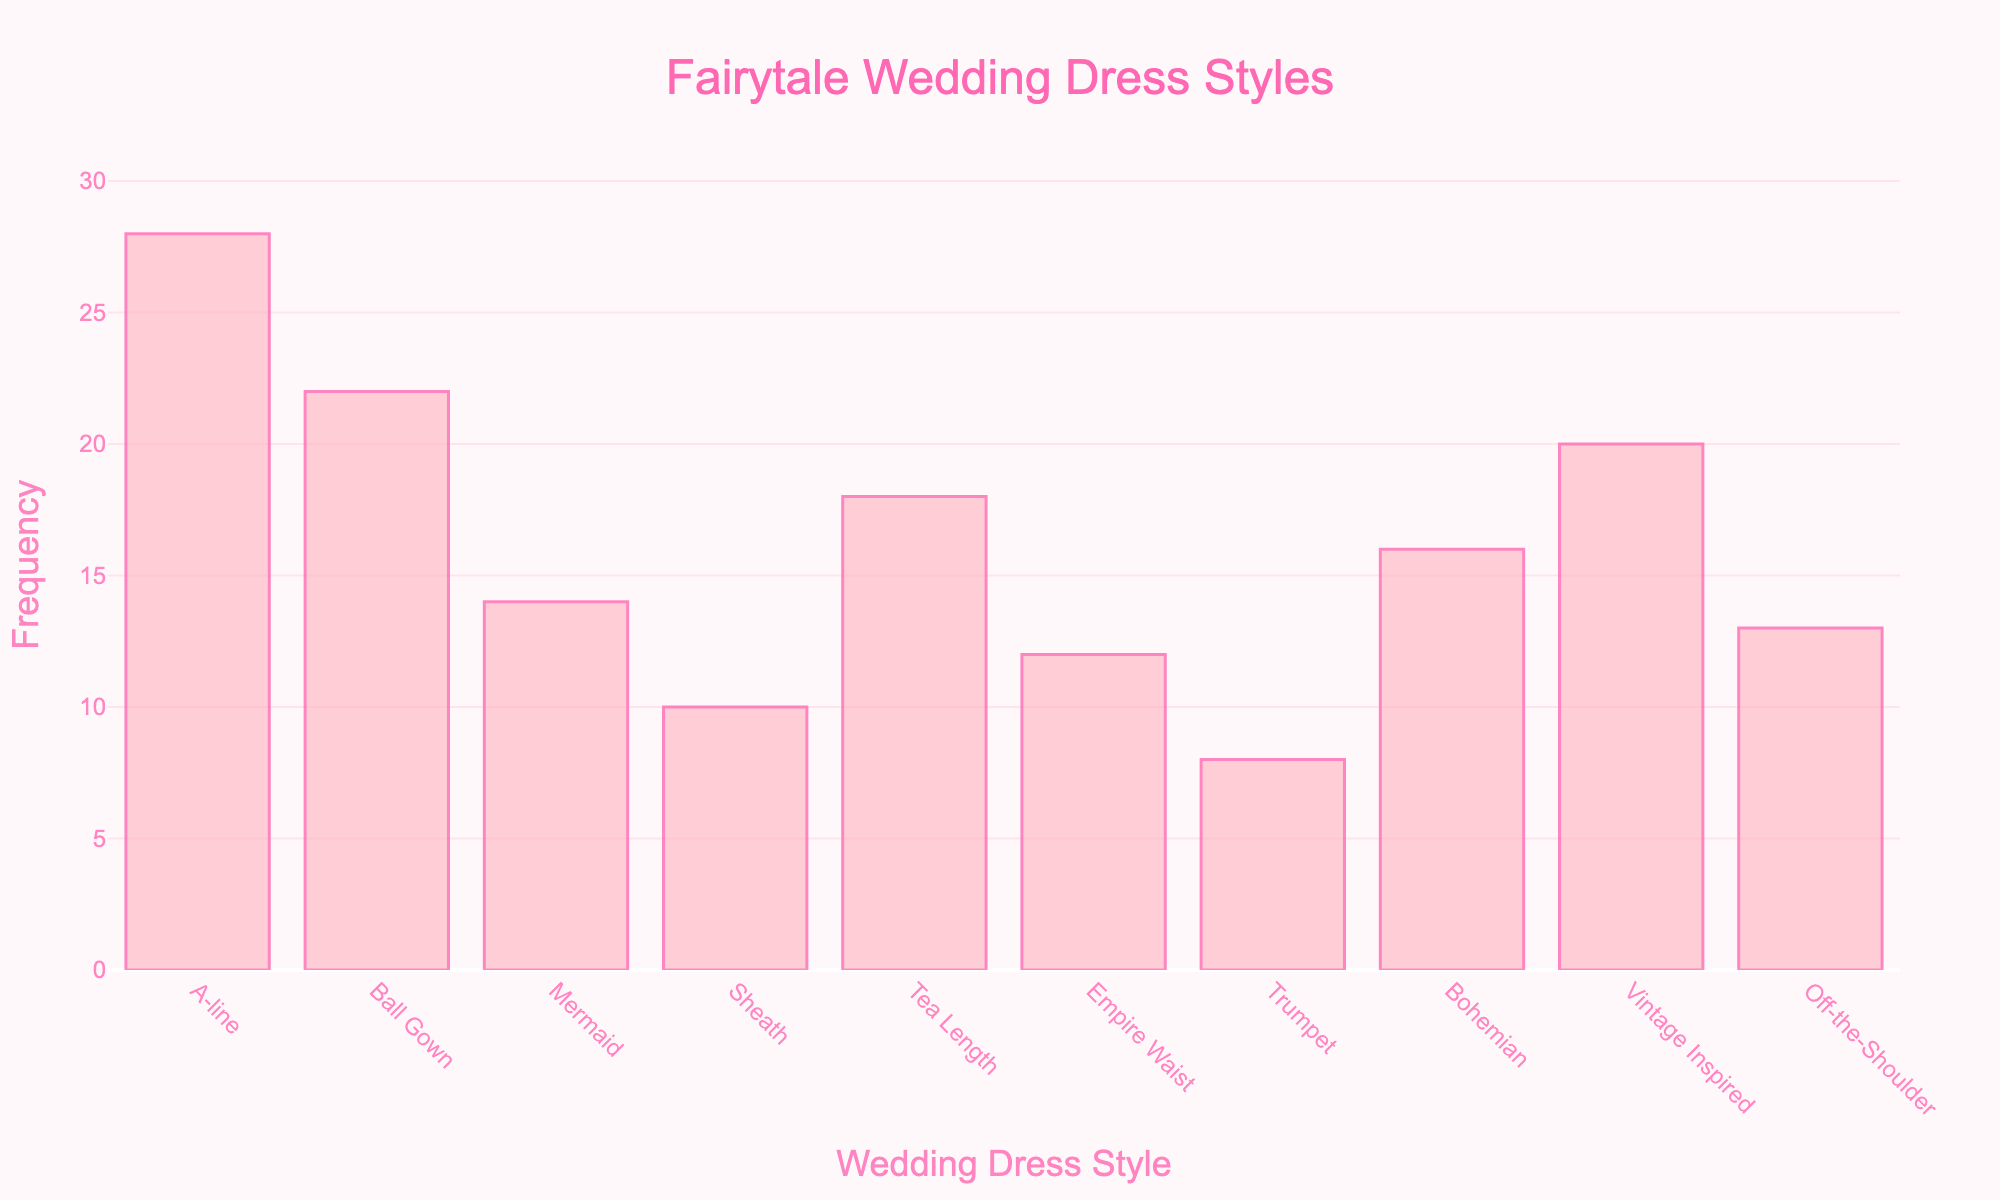What is the title of the histogram? The title of the histogram is prominently displayed at the top of the figure. It reads "Fairytale Wedding Dress Styles".
Answer: Fairytale Wedding Dress Styles What is the color used for the bars in the histogram? The bars in the histogram are colored in a light pink shade. This makes the bars visually distinctive against the background.
Answer: Light pink Which wedding dress style has the highest frequency? By observing the height of the bars, the "A-line" style has the highest frequency among the wedding dress styles with a frequency of 28.
Answer: A-line What is the second most popular wedding dress style among elementary school teachers? The second tallest bar represents the "Ball Gown" style, indicating it is the second most popular with a frequency of 22.
Answer: Ball Gown What is the total frequency of all wedding dress styles combined? To find the total frequency, sum the frequency values of all styles: 28 + 22 + 14 + 10 + 18 + 12 + 8 + 16 + 20 + 13 = 161.
Answer: 161 How many styles have a frequency greater than or equal to 18? The styles with frequencies >= 18 are A-line (28), Ball Gown (22), Tea Length (18), and Vintage Inspired (20). That's a total of 4 styles.
Answer: 4 What is the difference in frequency between the most popular and least popular wedding dress styles? The most popular style is A-line with a frequency of 28, and the least popular style is Trumpet with a frequency of 8. The difference is 28 - 8 = 20.
Answer: 20 Which style appears just more frequently than "Mermaid"? By comparing the bar heights, "Empire Waist" appears just more frequently than "Mermaid", with a frequency of 12 compared to Mermaid's 14.
Answer: Empire Waist What is the combined frequency of the Mermaid and Vintage Inspired styles? Adding the frequencies of "Mermaid" (14) and "Vintage Inspired" (20) gives a combined frequency of 14 + 20 = 34.
Answer: 34 How does the frequency of "Sheath" compare to "Off-the-Shoulder"? "Sheath" has a frequency of 10 and "Off-the-Shoulder" has a frequency of 13. Therefore, "Off-the-Shoulder" has a higher frequency than "Sheath".
Answer: Off-the-Shoulder has a higher frequency 